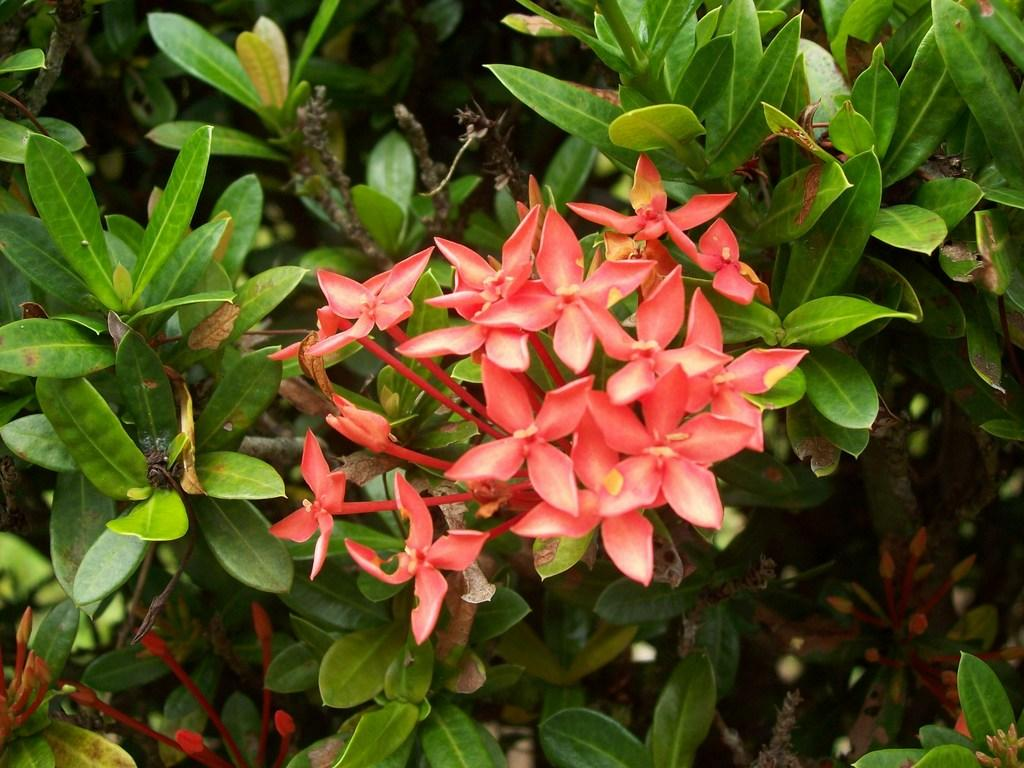What type of flowers are on the plant in the image? There are orange flowers on the plant in the image. Where are the birds located in the image? The birds are in the bottom left corner of the image. What can be seen on the left side of the image? There are many leaves on the left side of the image. What finger is the bird using to hold the plot in the image? There is no bird holding a plot in the image, and birds do not have fingers. 